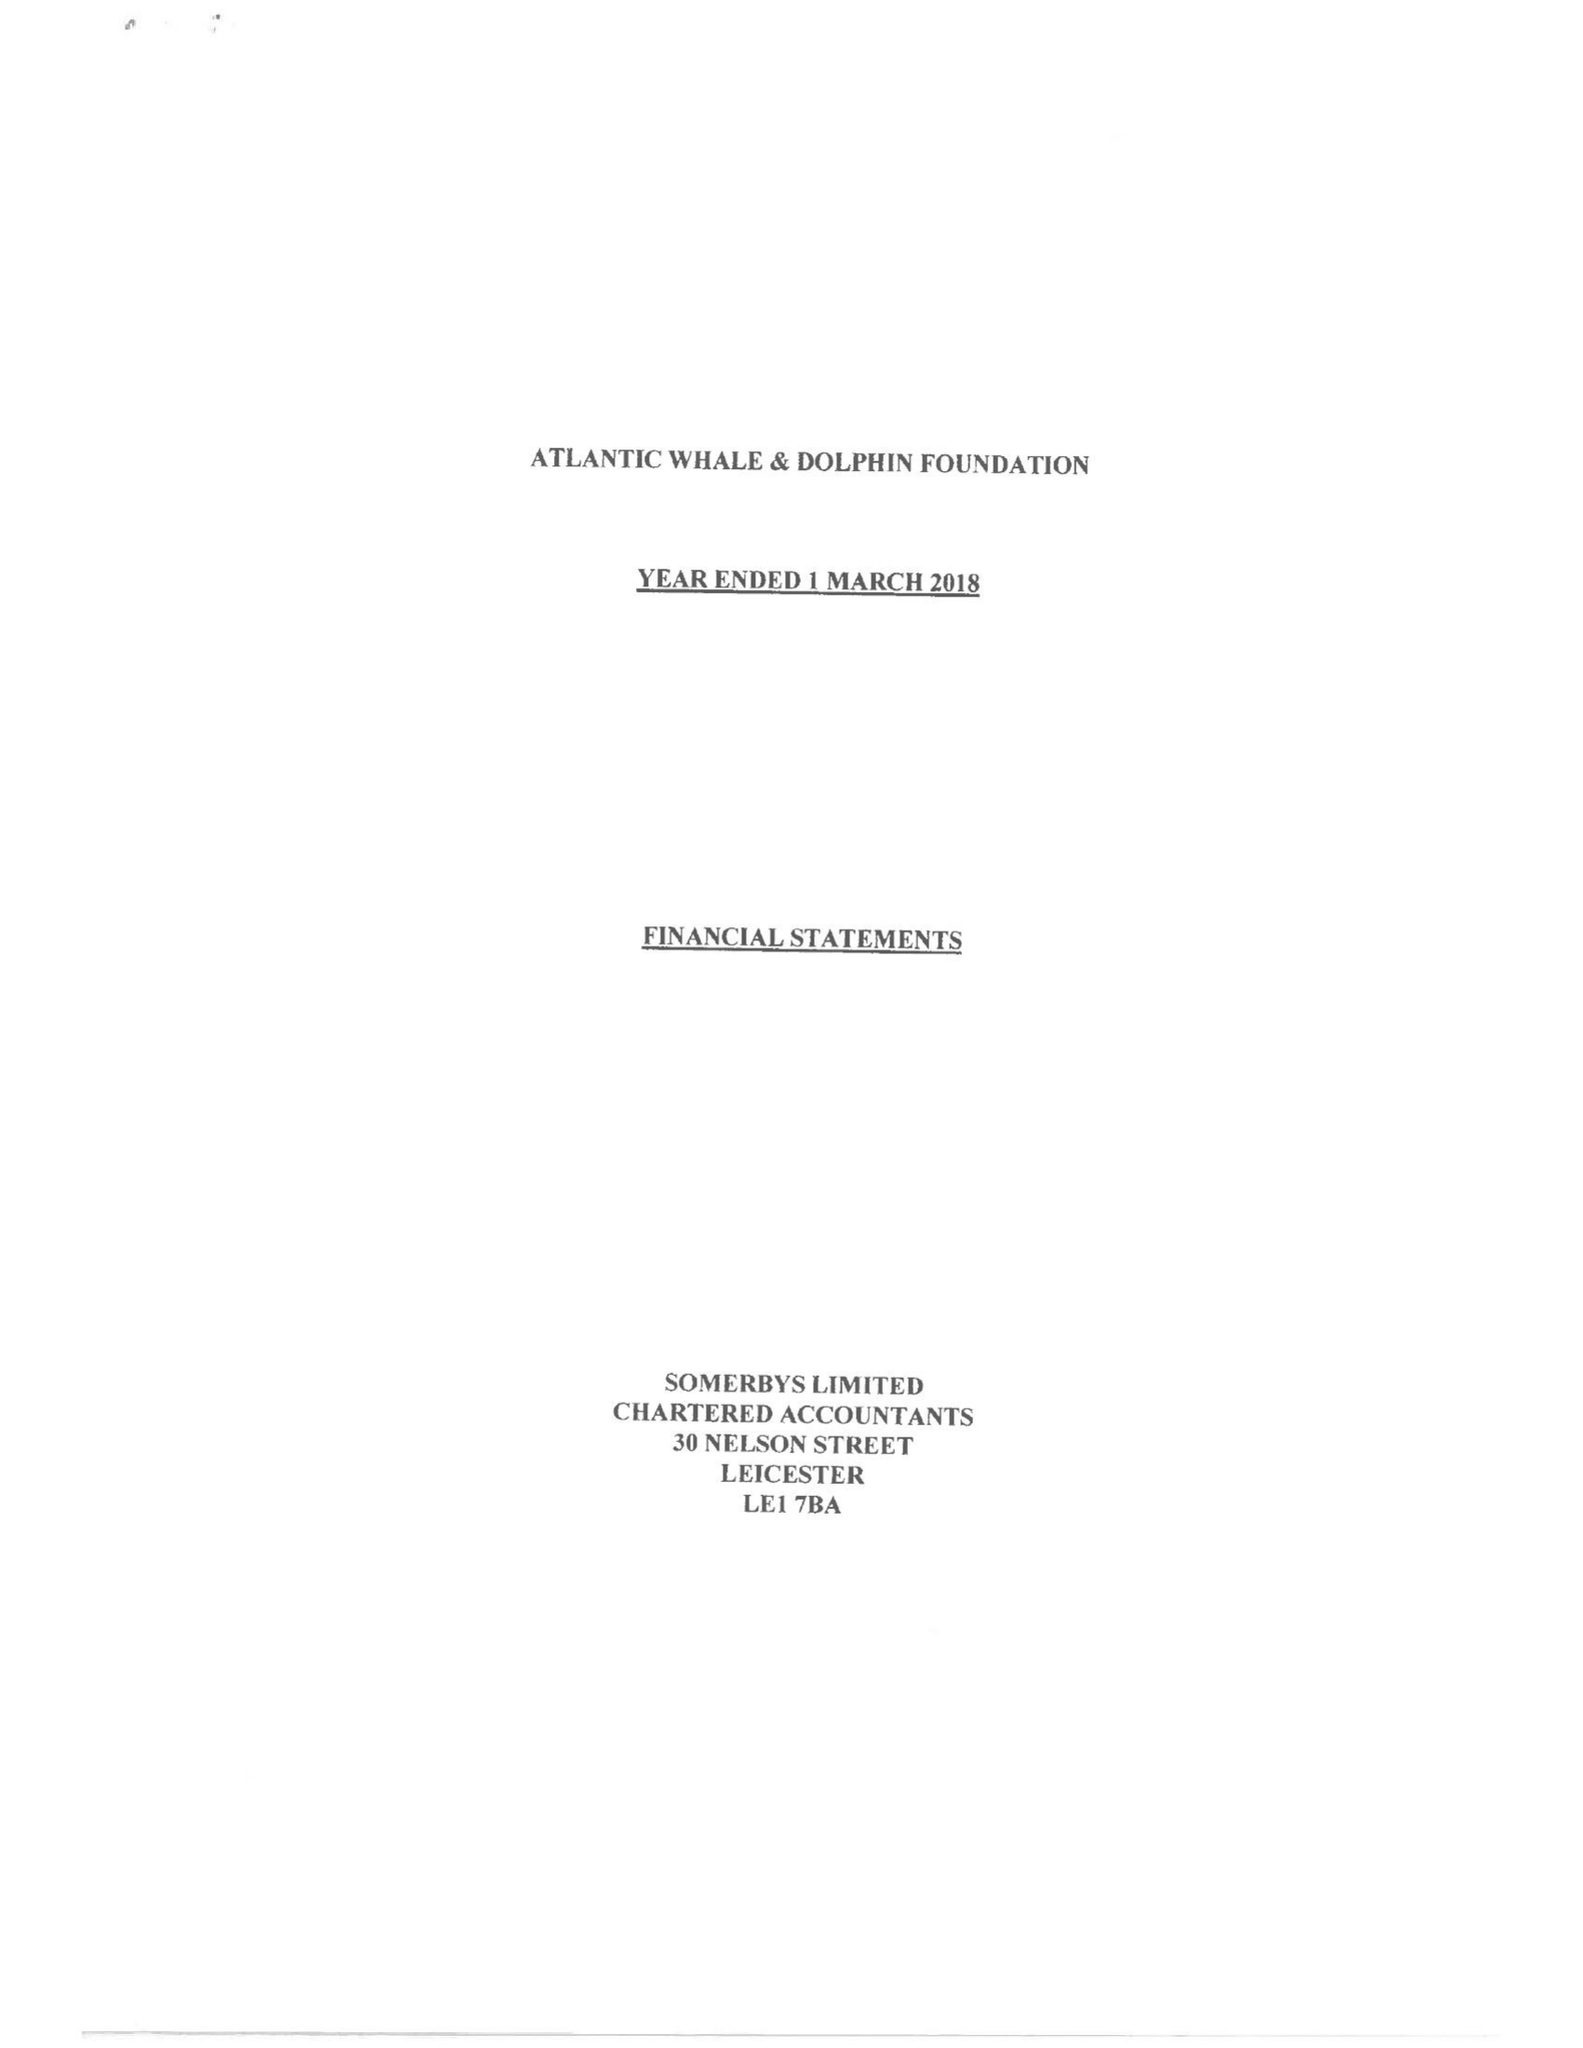What is the value for the address__post_town?
Answer the question using a single word or phrase. MARKET HARBOROUGH 